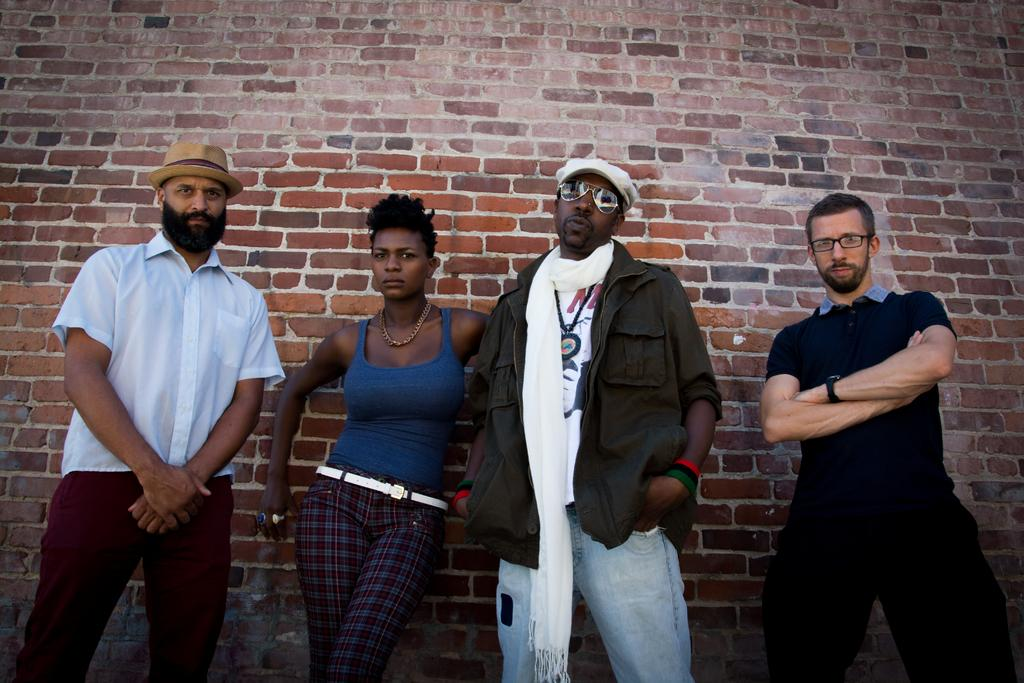How many people are in the foreground of the image? There are four people in the foreground of the image, including three men and one woman. What are the individuals in the foreground doing? The individuals are standing near a brick wall. What type of lead can be seen in the hands of the woman in the image? There is no lead visible in the hands of the woman in the image. Who is the creator of the brick wall in the image? The creator of the brick wall is not visible or identifiable in the image. 